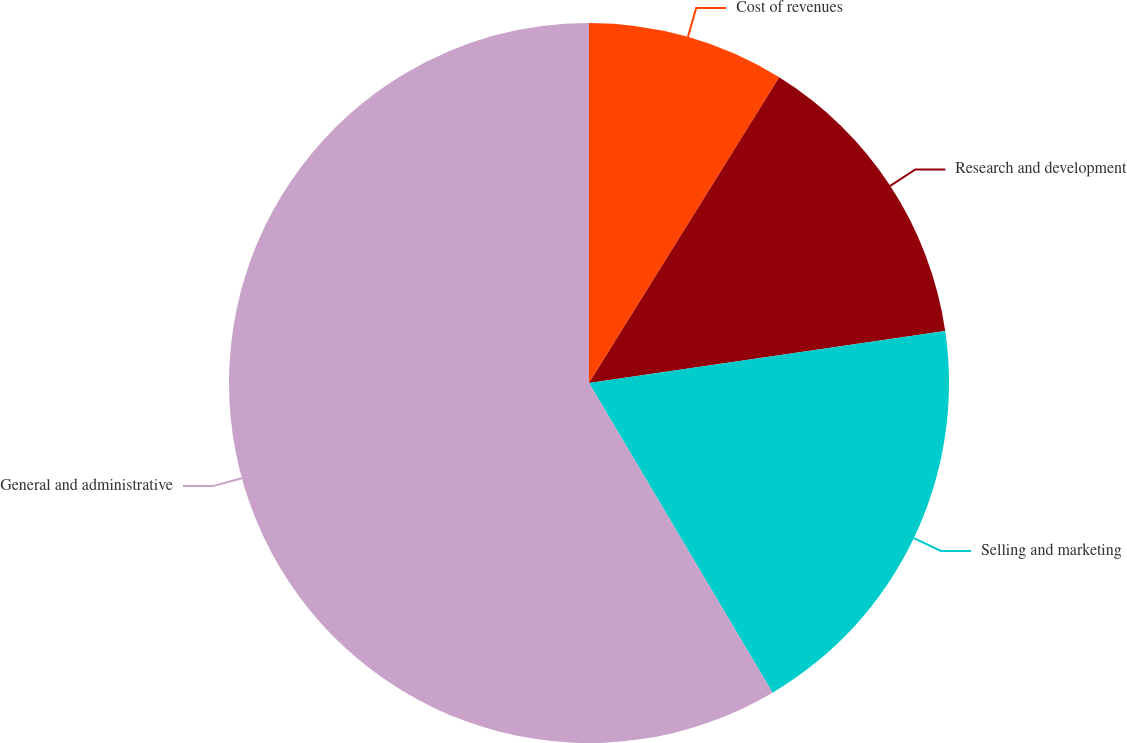Convert chart to OTSL. <chart><loc_0><loc_0><loc_500><loc_500><pie_chart><fcel>Cost of revenues<fcel>Research and development<fcel>Selling and marketing<fcel>General and administrative<nl><fcel>8.86%<fcel>13.83%<fcel>18.79%<fcel>58.51%<nl></chart> 